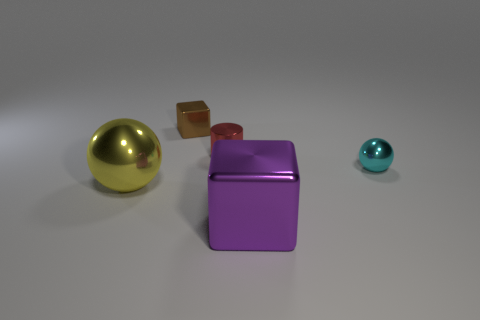Add 1 small balls. How many objects exist? 6 Subtract all yellow spheres. How many spheres are left? 1 Subtract all spheres. How many objects are left? 3 Subtract all brown cylinders. Subtract all green spheres. How many cylinders are left? 1 Subtract all big yellow balls. Subtract all small red objects. How many objects are left? 3 Add 3 tiny shiny things. How many tiny shiny things are left? 6 Add 2 purple objects. How many purple objects exist? 3 Subtract 0 green blocks. How many objects are left? 5 